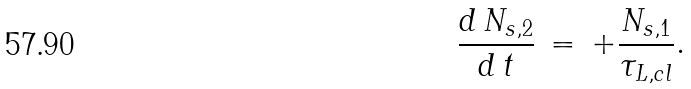Convert formula to latex. <formula><loc_0><loc_0><loc_500><loc_500>\frac { d \, N _ { s , 2 } } { d \, t } \, = \, + \frac { N _ { s , 1 } } { \tau _ { L , c l } } .</formula> 